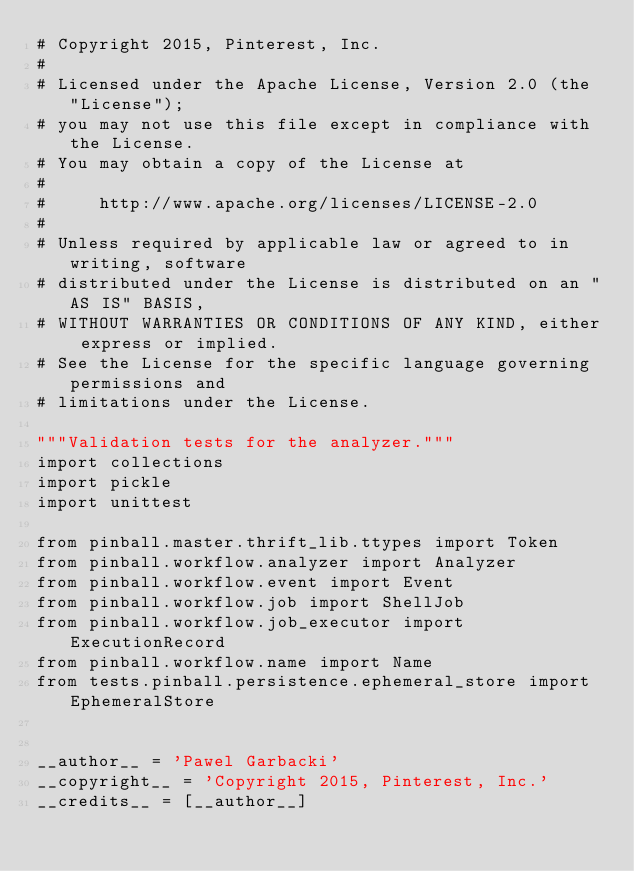Convert code to text. <code><loc_0><loc_0><loc_500><loc_500><_Python_># Copyright 2015, Pinterest, Inc.
#
# Licensed under the Apache License, Version 2.0 (the "License");
# you may not use this file except in compliance with the License.
# You may obtain a copy of the License at
#
#     http://www.apache.org/licenses/LICENSE-2.0
#
# Unless required by applicable law or agreed to in writing, software
# distributed under the License is distributed on an "AS IS" BASIS,
# WITHOUT WARRANTIES OR CONDITIONS OF ANY KIND, either express or implied.
# See the License for the specific language governing permissions and
# limitations under the License.

"""Validation tests for the analyzer."""
import collections
import pickle
import unittest

from pinball.master.thrift_lib.ttypes import Token
from pinball.workflow.analyzer import Analyzer
from pinball.workflow.event import Event
from pinball.workflow.job import ShellJob
from pinball.workflow.job_executor import ExecutionRecord
from pinball.workflow.name import Name
from tests.pinball.persistence.ephemeral_store import EphemeralStore


__author__ = 'Pawel Garbacki'
__copyright__ = 'Copyright 2015, Pinterest, Inc.'
__credits__ = [__author__]</code> 